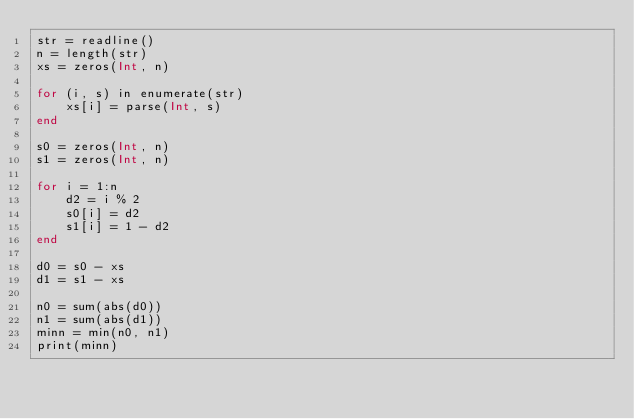Convert code to text. <code><loc_0><loc_0><loc_500><loc_500><_Julia_>str = readline()
n = length(str)
xs = zeros(Int, n)

for (i, s) in enumerate(str)
    xs[i] = parse(Int, s)
end

s0 = zeros(Int, n)
s1 = zeros(Int, n)

for i = 1:n
    d2 = i % 2
    s0[i] = d2
    s1[i] = 1 - d2
end

d0 = s0 - xs
d1 = s1 - xs

n0 = sum(abs(d0))
n1 = sum(abs(d1))
minn = min(n0, n1)
print(minn)
</code> 